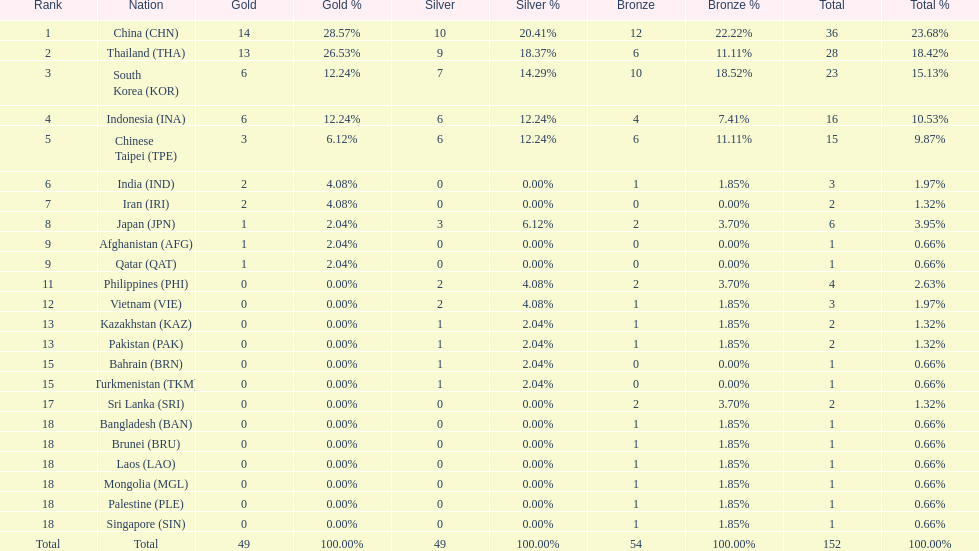How many nations obtained no silver medals whatsoever? 11. 